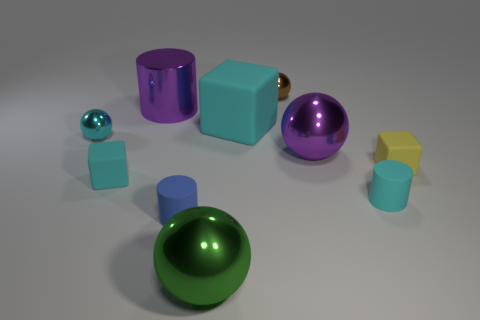There is a object on the left side of the tiny cyan matte block; what is its material?
Your answer should be compact. Metal. Does the brown metal object have the same shape as the purple shiny thing that is on the right side of the big matte cube?
Offer a very short reply. Yes. Are there more purple matte blocks than big green spheres?
Offer a very short reply. No. What is the shape of the small cyan thing that is the same material as the large green thing?
Your answer should be compact. Sphere. What is the material of the cyan block in front of the small thing that is on the right side of the cyan cylinder?
Offer a very short reply. Rubber. There is a purple shiny thing that is behind the small cyan ball; is it the same shape as the tiny blue thing?
Your answer should be very brief. Yes. Is the number of cyan metal spheres that are in front of the tiny brown ball greater than the number of gray rubber blocks?
Your response must be concise. Yes. Is there anything else that is made of the same material as the small blue cylinder?
Provide a short and direct response. Yes. There is a shiny thing that is the same color as the metallic cylinder; what shape is it?
Ensure brevity in your answer.  Sphere. How many blocks are either small blue matte things or tiny yellow matte things?
Your response must be concise. 1. 